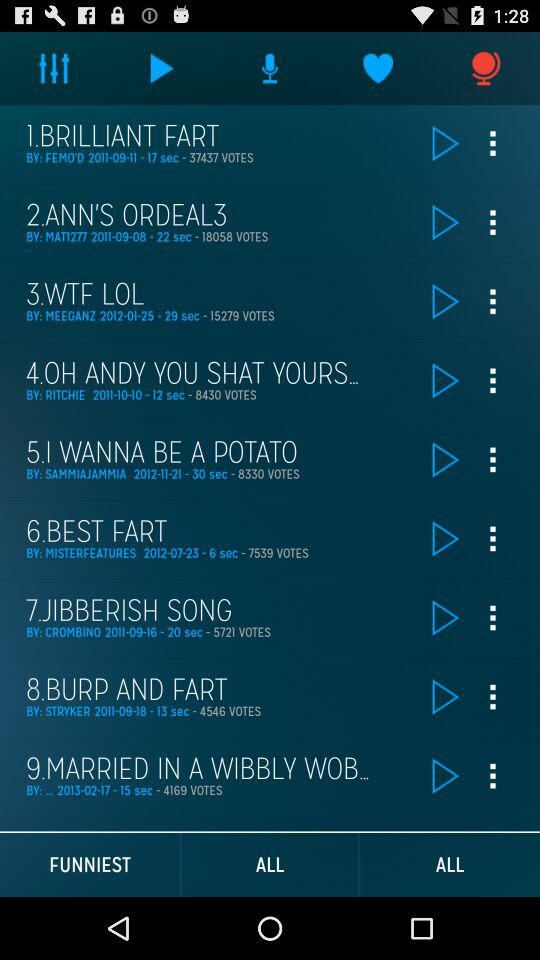Who is the singer of burp and fart? The singer of burp and fart is STRYKER. 